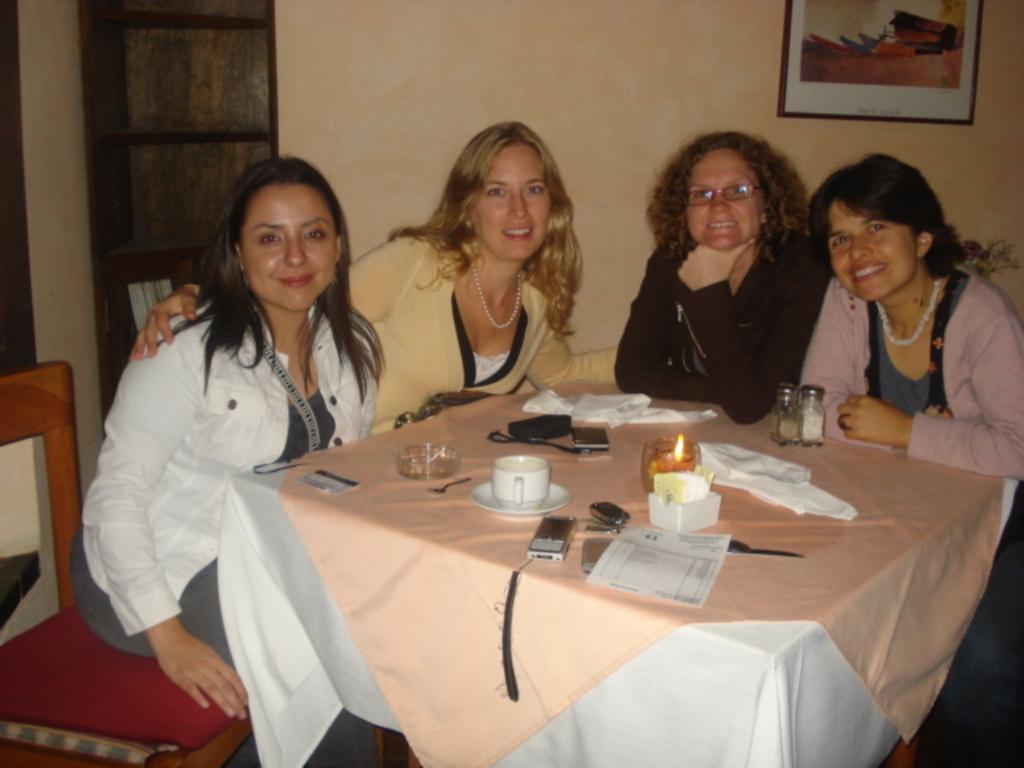Describe this image in one or two sentences. In the center we can see four persons were sitting on the chair around the table and they were smiling. On table we can see cup,saucer,ipod,paper,candle,napkin,phone,box,spoon,card and bottle. In the background there is a wall,photo frame and door. 